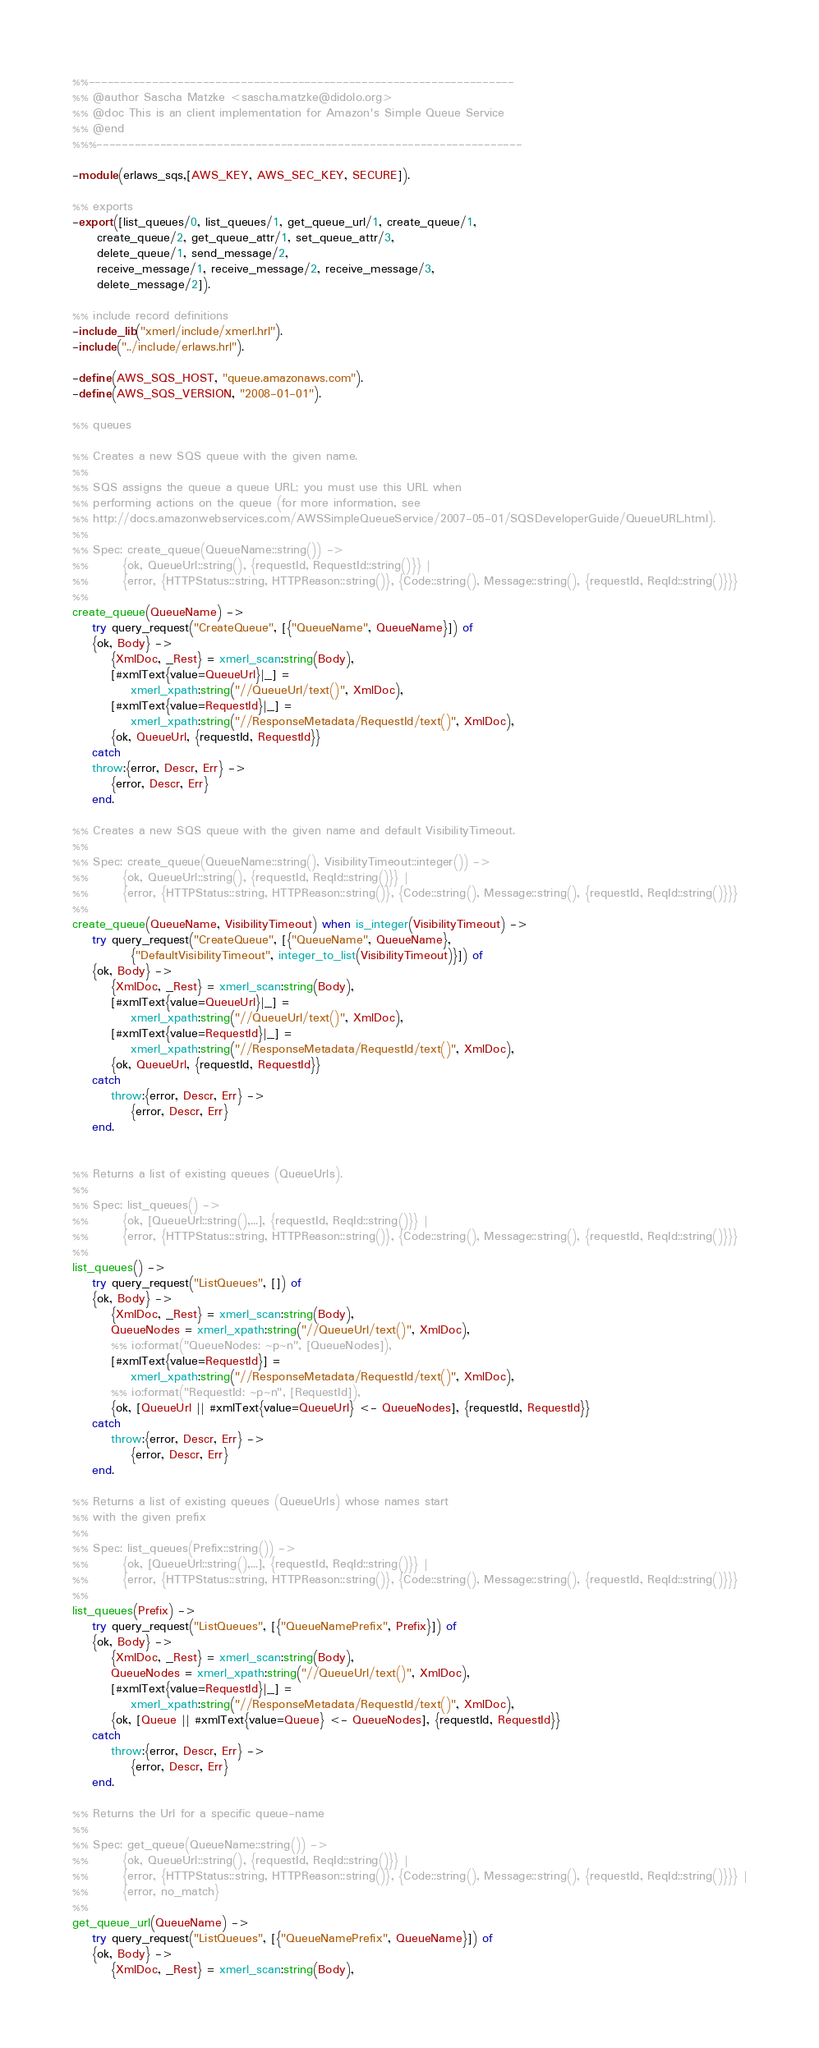<code> <loc_0><loc_0><loc_500><loc_500><_Erlang_>%%-------------------------------------------------------------------
%% @author Sascha Matzke <sascha.matzke@didolo.org>
%% @doc This is an client implementation for Amazon's Simple Queue Service
%% @end
%%%-------------------------------------------------------------------

-module(erlaws_sqs,[AWS_KEY, AWS_SEC_KEY, SECURE]).

%% exports
-export([list_queues/0, list_queues/1, get_queue_url/1, create_queue/1,
	 create_queue/2, get_queue_attr/1, set_queue_attr/3, 
	 delete_queue/1, send_message/2, 
	 receive_message/1, receive_message/2, receive_message/3,
	 delete_message/2]).

%% include record definitions
-include_lib("xmerl/include/xmerl.hrl").
-include("../include/erlaws.hrl").

-define(AWS_SQS_HOST, "queue.amazonaws.com").
-define(AWS_SQS_VERSION, "2008-01-01").

%% queues

%% Creates a new SQS queue with the given name. 
%%
%% SQS assigns the queue a queue URL; you must use this URL when 
%% performing actions on the queue (for more information, see 
%% http://docs.amazonwebservices.com/AWSSimpleQueueService/2007-05-01/SQSDeveloperGuide/QueueURL.html).
%%
%% Spec: create_queue(QueueName::string()) ->
%%       {ok, QueueUrl::string(), {requestId, RequestId::string()}} |
%%       {error, {HTTPStatus::string, HTTPReason::string()}, {Code::string(), Message::string(), {requestId, ReqId::string()}}}
%% 
create_queue(QueueName) ->
    try query_request("CreateQueue", [{"QueueName", QueueName}]) of
	{ok, Body} ->
	    {XmlDoc, _Rest} = xmerl_scan:string(Body),
	    [#xmlText{value=QueueUrl}|_] = 
			xmerl_xpath:string("//QueueUrl/text()", XmlDoc),
		[#xmlText{value=RequestId}|_] =
			xmerl_xpath:string("//ResponseMetadata/RequestId/text()", XmlDoc),
	    {ok, QueueUrl, {requestId, RequestId}}
    catch
	throw:{error, Descr, Err} ->
	    {error, Descr, Err}
    end.

%% Creates a new SQS queue with the given name and default VisibilityTimeout.
%% 
%% Spec: create_queue(QueueName::string(), VisibilityTimeout::integer()) ->
%%       {ok, QueueUrl::string(), {requestId, ReqId::string()}} |
%%       {error, {HTTPStatus::string, HTTPReason::string()}, {Code::string(), Message::string(), {requestId, ReqId::string()}}}
%% 
create_queue(QueueName, VisibilityTimeout) when is_integer(VisibilityTimeout) ->
    try query_request("CreateQueue", [{"QueueName", QueueName}, 
		    {"DefaultVisibilityTimeout", integer_to_list(VisibilityTimeout)}]) of
	{ok, Body} ->
	    {XmlDoc, _Rest} = xmerl_scan:string(Body),
	    [#xmlText{value=QueueUrl}|_] = 
			xmerl_xpath:string("//QueueUrl/text()", XmlDoc),
		[#xmlText{value=RequestId}|_] =
			xmerl_xpath:string("//ResponseMetadata/RequestId/text()", XmlDoc),
	    {ok, QueueUrl, {requestId, RequestId}}
    catch
		throw:{error, Descr, Err} ->
	    	{error, Descr, Err}
    end.
	

%% Returns a list of existing queues (QueueUrls).
%%
%% Spec: list_queues() ->
%%       {ok, [QueueUrl::string(),...], {requestId, ReqId::string()}} |
%%       {error, {HTTPStatus::string, HTTPReason::string()}, {Code::string(), Message::string(), {requestId, ReqId::string()}}}
%%
list_queues() ->
    try query_request("ListQueues", []) of
	{ok, Body} ->
	    {XmlDoc, _Rest} = xmerl_scan:string(Body),
	    QueueNodes = xmerl_xpath:string("//QueueUrl/text()", XmlDoc),
		%% io:format("QueueNodes: ~p~n", [QueueNodes]),
		[#xmlText{value=RequestId}] =
			xmerl_xpath:string("//ResponseMetadata/RequestId/text()", XmlDoc),
		%% io:format("RequestId: ~p~n", [RequestId]),
	    {ok, [QueueUrl || #xmlText{value=QueueUrl} <- QueueNodes], {requestId, RequestId}}
    catch
		throw:{error, Descr, Err} ->
	    	{error, Descr, Err}
    end.

%% Returns a list of existing queues (QueueUrls) whose names start
%% with the given prefix
%%
%% Spec: list_queues(Prefix::string()) ->
%%       {ok, [QueueUrl::string(),...], {requestId, ReqId::string()}} |
%%       {error, {HTTPStatus::string, HTTPReason::string()}, {Code::string(), Message::string(), {requestId, ReqId::string()}}}
%%
list_queues(Prefix) ->
    try query_request("ListQueues", [{"QueueNamePrefix", Prefix}]) of
	{ok, Body} ->
	    {XmlDoc, _Rest} = xmerl_scan:string(Body),
	    QueueNodes = xmerl_xpath:string("//QueueUrl/text()", XmlDoc),
		[#xmlText{value=RequestId}|_] =
			xmerl_xpath:string("//ResponseMetadata/RequestId/text()", XmlDoc),
	    {ok, [Queue || #xmlText{value=Queue} <- QueueNodes], {requestId, RequestId}}
    catch
		throw:{error, Descr, Err} ->
	    	{error, Descr, Err}
    end.
    
%% Returns the Url for a specific queue-name
%%
%% Spec: get_queue(QueueName::string()) ->
%%       {ok, QueueUrl::string(), {requestId, ReqId::string()}} |
%%       {error, {HTTPStatus::string, HTTPReason::string()}, {Code::string(), Message::string(), {requestId, ReqId::string()}}} |
%%       {error, no_match}
%%
get_queue_url(QueueName) ->
    try query_request("ListQueues", [{"QueueNamePrefix", QueueName}]) of
	{ok, Body} ->
	    {XmlDoc, _Rest} = xmerl_scan:string(Body),	    </code> 